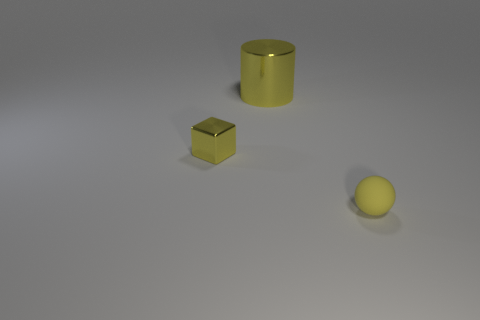What is the material of the ball?
Offer a terse response. Rubber. Is the shape of the tiny yellow object that is behind the matte sphere the same as  the yellow matte thing?
Offer a very short reply. No. What is the size of the metal cube that is the same color as the large shiny thing?
Your response must be concise. Small. Are there any yellow metallic cylinders of the same size as the yellow rubber sphere?
Make the answer very short. No. There is a yellow thing behind the small yellow object that is left of the large cylinder; are there any matte balls on the left side of it?
Offer a terse response. No. Does the tiny rubber ball have the same color as the tiny object that is behind the matte sphere?
Your answer should be very brief. Yes. What is the material of the yellow object that is in front of the yellow thing on the left side of the yellow shiny object that is right of the tiny yellow metal block?
Keep it short and to the point. Rubber. What shape is the tiny thing on the right side of the cylinder?
Give a very brief answer. Sphere. The object that is the same material as the yellow cube is what size?
Keep it short and to the point. Large. What number of other big things are the same shape as the big yellow metal object?
Your response must be concise. 0. 